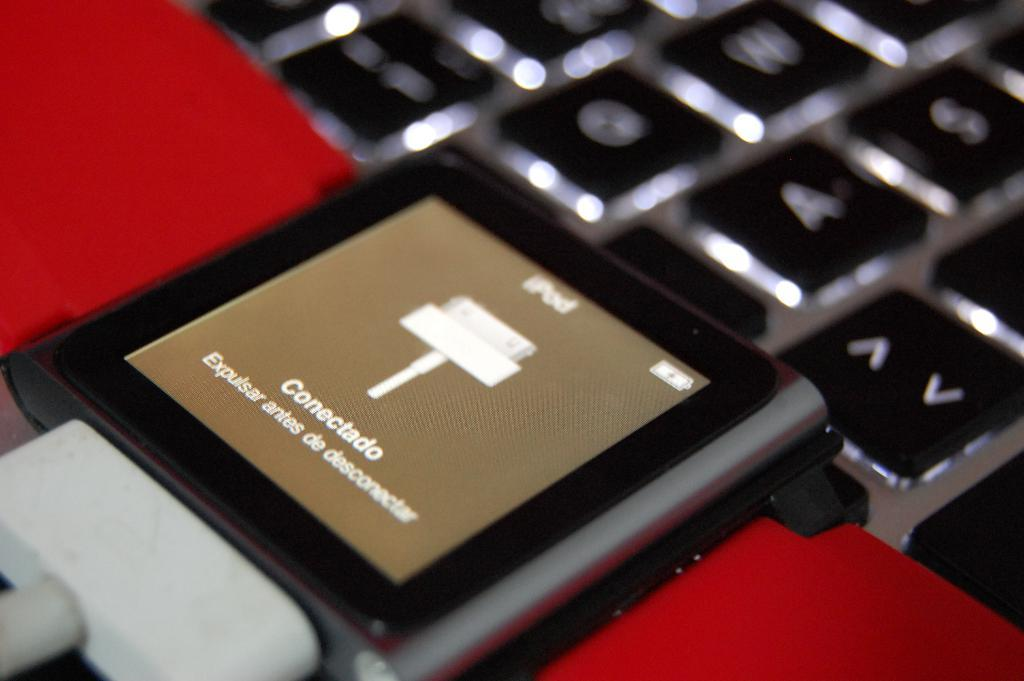What color is the charger in the image? The charger in the image is white-colored. What device is the charger connected to? The charger is connected to an iPod. What other electronic device is visible in the image? There is a keyboard in the image. Where is the keyboard located in the image? The keyboard is at the top of the image. Can you see a snail crawling on the keyboard in the image? No, there is no snail present in the image. 